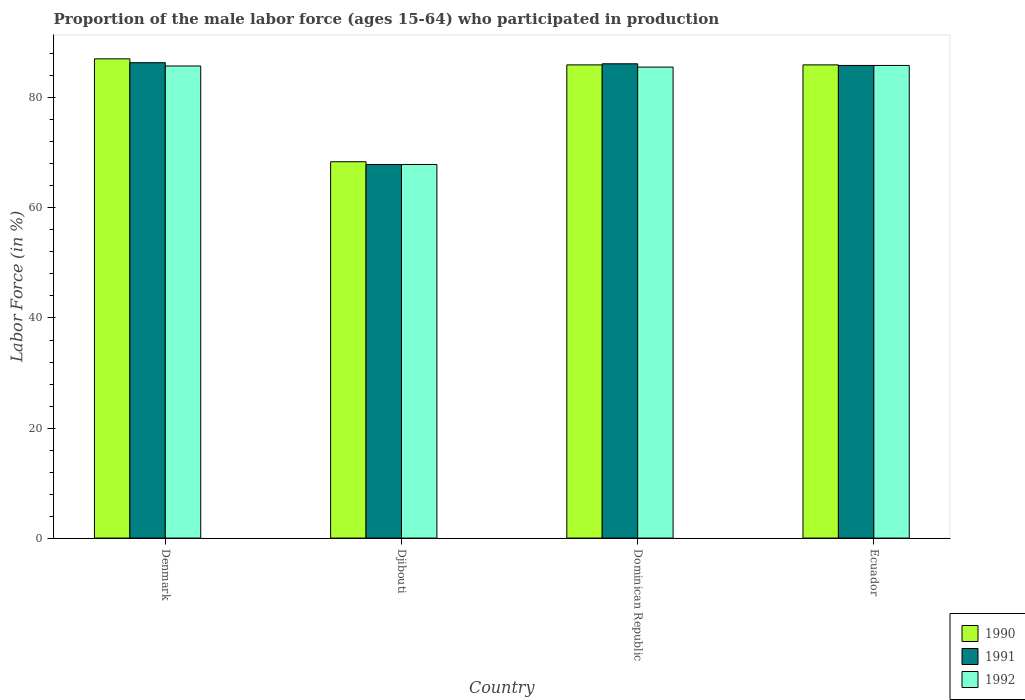How many groups of bars are there?
Provide a short and direct response. 4. How many bars are there on the 1st tick from the left?
Your answer should be compact. 3. What is the label of the 3rd group of bars from the left?
Keep it short and to the point. Dominican Republic. What is the proportion of the male labor force who participated in production in 1992 in Djibouti?
Keep it short and to the point. 67.9. Across all countries, what is the maximum proportion of the male labor force who participated in production in 1992?
Your answer should be compact. 85.9. Across all countries, what is the minimum proportion of the male labor force who participated in production in 1990?
Give a very brief answer. 68.4. In which country was the proportion of the male labor force who participated in production in 1991 minimum?
Provide a succinct answer. Djibouti. What is the total proportion of the male labor force who participated in production in 1992 in the graph?
Provide a succinct answer. 325.2. What is the difference between the proportion of the male labor force who participated in production in 1990 in Djibouti and that in Dominican Republic?
Keep it short and to the point. -17.6. What is the difference between the proportion of the male labor force who participated in production in 1992 in Dominican Republic and the proportion of the male labor force who participated in production in 1990 in Ecuador?
Your response must be concise. -0.4. What is the average proportion of the male labor force who participated in production in 1992 per country?
Your answer should be compact. 81.3. What is the ratio of the proportion of the male labor force who participated in production in 1991 in Djibouti to that in Ecuador?
Your answer should be very brief. 0.79. Is the proportion of the male labor force who participated in production in 1992 in Dominican Republic less than that in Ecuador?
Offer a very short reply. Yes. Is the difference between the proportion of the male labor force who participated in production in 1992 in Dominican Republic and Ecuador greater than the difference between the proportion of the male labor force who participated in production in 1990 in Dominican Republic and Ecuador?
Your answer should be very brief. No. What is the difference between the highest and the second highest proportion of the male labor force who participated in production in 1991?
Keep it short and to the point. 0.3. What is the difference between the highest and the lowest proportion of the male labor force who participated in production in 1992?
Provide a short and direct response. 18. In how many countries, is the proportion of the male labor force who participated in production in 1990 greater than the average proportion of the male labor force who participated in production in 1990 taken over all countries?
Keep it short and to the point. 3. Is it the case that in every country, the sum of the proportion of the male labor force who participated in production in 1990 and proportion of the male labor force who participated in production in 1991 is greater than the proportion of the male labor force who participated in production in 1992?
Keep it short and to the point. Yes. Does the graph contain any zero values?
Your answer should be compact. No. Does the graph contain grids?
Provide a short and direct response. No. How many legend labels are there?
Give a very brief answer. 3. How are the legend labels stacked?
Your answer should be compact. Vertical. What is the title of the graph?
Provide a succinct answer. Proportion of the male labor force (ages 15-64) who participated in production. Does "1962" appear as one of the legend labels in the graph?
Offer a terse response. No. What is the label or title of the Y-axis?
Make the answer very short. Labor Force (in %). What is the Labor Force (in %) of 1990 in Denmark?
Make the answer very short. 87.1. What is the Labor Force (in %) in 1991 in Denmark?
Ensure brevity in your answer.  86.4. What is the Labor Force (in %) of 1992 in Denmark?
Your answer should be very brief. 85.8. What is the Labor Force (in %) of 1990 in Djibouti?
Provide a short and direct response. 68.4. What is the Labor Force (in %) in 1991 in Djibouti?
Your answer should be compact. 67.9. What is the Labor Force (in %) of 1992 in Djibouti?
Provide a short and direct response. 67.9. What is the Labor Force (in %) of 1991 in Dominican Republic?
Ensure brevity in your answer.  86.2. What is the Labor Force (in %) in 1992 in Dominican Republic?
Keep it short and to the point. 85.6. What is the Labor Force (in %) in 1991 in Ecuador?
Your answer should be very brief. 85.9. What is the Labor Force (in %) of 1992 in Ecuador?
Ensure brevity in your answer.  85.9. Across all countries, what is the maximum Labor Force (in %) in 1990?
Offer a terse response. 87.1. Across all countries, what is the maximum Labor Force (in %) of 1991?
Your answer should be very brief. 86.4. Across all countries, what is the maximum Labor Force (in %) in 1992?
Give a very brief answer. 85.9. Across all countries, what is the minimum Labor Force (in %) in 1990?
Your response must be concise. 68.4. Across all countries, what is the minimum Labor Force (in %) in 1991?
Your response must be concise. 67.9. Across all countries, what is the minimum Labor Force (in %) of 1992?
Your answer should be compact. 67.9. What is the total Labor Force (in %) of 1990 in the graph?
Provide a succinct answer. 327.5. What is the total Labor Force (in %) in 1991 in the graph?
Provide a succinct answer. 326.4. What is the total Labor Force (in %) of 1992 in the graph?
Offer a very short reply. 325.2. What is the difference between the Labor Force (in %) in 1990 in Denmark and that in Djibouti?
Ensure brevity in your answer.  18.7. What is the difference between the Labor Force (in %) in 1991 in Denmark and that in Djibouti?
Your answer should be very brief. 18.5. What is the difference between the Labor Force (in %) of 1990 in Denmark and that in Dominican Republic?
Give a very brief answer. 1.1. What is the difference between the Labor Force (in %) of 1991 in Denmark and that in Dominican Republic?
Give a very brief answer. 0.2. What is the difference between the Labor Force (in %) in 1991 in Denmark and that in Ecuador?
Make the answer very short. 0.5. What is the difference between the Labor Force (in %) in 1992 in Denmark and that in Ecuador?
Keep it short and to the point. -0.1. What is the difference between the Labor Force (in %) in 1990 in Djibouti and that in Dominican Republic?
Provide a succinct answer. -17.6. What is the difference between the Labor Force (in %) in 1991 in Djibouti and that in Dominican Republic?
Provide a short and direct response. -18.3. What is the difference between the Labor Force (in %) of 1992 in Djibouti and that in Dominican Republic?
Ensure brevity in your answer.  -17.7. What is the difference between the Labor Force (in %) in 1990 in Djibouti and that in Ecuador?
Offer a very short reply. -17.6. What is the difference between the Labor Force (in %) in 1991 in Djibouti and that in Ecuador?
Offer a very short reply. -18. What is the difference between the Labor Force (in %) in 1992 in Djibouti and that in Ecuador?
Give a very brief answer. -18. What is the difference between the Labor Force (in %) of 1991 in Dominican Republic and that in Ecuador?
Offer a terse response. 0.3. What is the difference between the Labor Force (in %) in 1990 in Denmark and the Labor Force (in %) in 1991 in Djibouti?
Offer a very short reply. 19.2. What is the difference between the Labor Force (in %) of 1991 in Denmark and the Labor Force (in %) of 1992 in Djibouti?
Your response must be concise. 18.5. What is the difference between the Labor Force (in %) in 1990 in Denmark and the Labor Force (in %) in 1991 in Dominican Republic?
Offer a terse response. 0.9. What is the difference between the Labor Force (in %) of 1990 in Denmark and the Labor Force (in %) of 1992 in Dominican Republic?
Offer a very short reply. 1.5. What is the difference between the Labor Force (in %) in 1991 in Denmark and the Labor Force (in %) in 1992 in Dominican Republic?
Offer a very short reply. 0.8. What is the difference between the Labor Force (in %) in 1990 in Denmark and the Labor Force (in %) in 1992 in Ecuador?
Give a very brief answer. 1.2. What is the difference between the Labor Force (in %) in 1990 in Djibouti and the Labor Force (in %) in 1991 in Dominican Republic?
Offer a terse response. -17.8. What is the difference between the Labor Force (in %) in 1990 in Djibouti and the Labor Force (in %) in 1992 in Dominican Republic?
Offer a very short reply. -17.2. What is the difference between the Labor Force (in %) of 1991 in Djibouti and the Labor Force (in %) of 1992 in Dominican Republic?
Your answer should be compact. -17.7. What is the difference between the Labor Force (in %) of 1990 in Djibouti and the Labor Force (in %) of 1991 in Ecuador?
Keep it short and to the point. -17.5. What is the difference between the Labor Force (in %) in 1990 in Djibouti and the Labor Force (in %) in 1992 in Ecuador?
Offer a very short reply. -17.5. What is the difference between the Labor Force (in %) of 1990 in Dominican Republic and the Labor Force (in %) of 1991 in Ecuador?
Ensure brevity in your answer.  0.1. What is the difference between the Labor Force (in %) in 1990 in Dominican Republic and the Labor Force (in %) in 1992 in Ecuador?
Offer a very short reply. 0.1. What is the difference between the Labor Force (in %) in 1991 in Dominican Republic and the Labor Force (in %) in 1992 in Ecuador?
Provide a short and direct response. 0.3. What is the average Labor Force (in %) of 1990 per country?
Provide a succinct answer. 81.88. What is the average Labor Force (in %) in 1991 per country?
Keep it short and to the point. 81.6. What is the average Labor Force (in %) in 1992 per country?
Ensure brevity in your answer.  81.3. What is the difference between the Labor Force (in %) of 1991 and Labor Force (in %) of 1992 in Denmark?
Give a very brief answer. 0.6. What is the difference between the Labor Force (in %) in 1990 and Labor Force (in %) in 1991 in Djibouti?
Your answer should be very brief. 0.5. What is the difference between the Labor Force (in %) of 1991 and Labor Force (in %) of 1992 in Djibouti?
Offer a terse response. 0. What is the difference between the Labor Force (in %) of 1990 and Labor Force (in %) of 1991 in Dominican Republic?
Provide a short and direct response. -0.2. What is the difference between the Labor Force (in %) in 1991 and Labor Force (in %) in 1992 in Dominican Republic?
Give a very brief answer. 0.6. What is the difference between the Labor Force (in %) in 1990 and Labor Force (in %) in 1991 in Ecuador?
Make the answer very short. 0.1. What is the difference between the Labor Force (in %) of 1990 and Labor Force (in %) of 1992 in Ecuador?
Keep it short and to the point. 0.1. What is the difference between the Labor Force (in %) in 1991 and Labor Force (in %) in 1992 in Ecuador?
Give a very brief answer. 0. What is the ratio of the Labor Force (in %) of 1990 in Denmark to that in Djibouti?
Keep it short and to the point. 1.27. What is the ratio of the Labor Force (in %) in 1991 in Denmark to that in Djibouti?
Provide a succinct answer. 1.27. What is the ratio of the Labor Force (in %) of 1992 in Denmark to that in Djibouti?
Provide a succinct answer. 1.26. What is the ratio of the Labor Force (in %) in 1990 in Denmark to that in Dominican Republic?
Offer a very short reply. 1.01. What is the ratio of the Labor Force (in %) of 1991 in Denmark to that in Dominican Republic?
Your answer should be compact. 1. What is the ratio of the Labor Force (in %) of 1990 in Denmark to that in Ecuador?
Ensure brevity in your answer.  1.01. What is the ratio of the Labor Force (in %) in 1991 in Denmark to that in Ecuador?
Offer a terse response. 1.01. What is the ratio of the Labor Force (in %) in 1990 in Djibouti to that in Dominican Republic?
Ensure brevity in your answer.  0.8. What is the ratio of the Labor Force (in %) in 1991 in Djibouti to that in Dominican Republic?
Give a very brief answer. 0.79. What is the ratio of the Labor Force (in %) of 1992 in Djibouti to that in Dominican Republic?
Provide a succinct answer. 0.79. What is the ratio of the Labor Force (in %) of 1990 in Djibouti to that in Ecuador?
Make the answer very short. 0.8. What is the ratio of the Labor Force (in %) in 1991 in Djibouti to that in Ecuador?
Ensure brevity in your answer.  0.79. What is the ratio of the Labor Force (in %) in 1992 in Djibouti to that in Ecuador?
Make the answer very short. 0.79. What is the ratio of the Labor Force (in %) in 1990 in Dominican Republic to that in Ecuador?
Ensure brevity in your answer.  1. What is the ratio of the Labor Force (in %) of 1991 in Dominican Republic to that in Ecuador?
Provide a succinct answer. 1. What is the difference between the highest and the second highest Labor Force (in %) in 1990?
Give a very brief answer. 1.1. What is the difference between the highest and the second highest Labor Force (in %) in 1992?
Give a very brief answer. 0.1. What is the difference between the highest and the lowest Labor Force (in %) in 1991?
Offer a terse response. 18.5. 